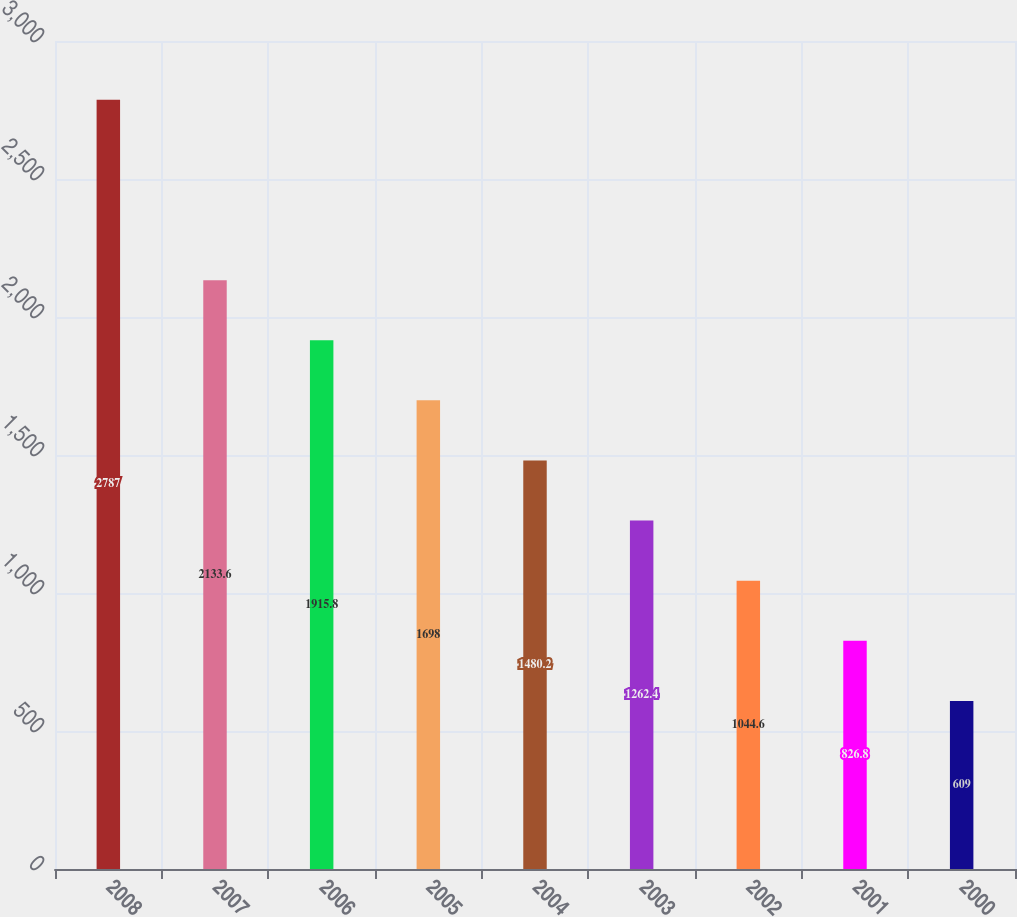Convert chart to OTSL. <chart><loc_0><loc_0><loc_500><loc_500><bar_chart><fcel>2008<fcel>2007<fcel>2006<fcel>2005<fcel>2004<fcel>2003<fcel>2002<fcel>2001<fcel>2000<nl><fcel>2787<fcel>2133.6<fcel>1915.8<fcel>1698<fcel>1480.2<fcel>1262.4<fcel>1044.6<fcel>826.8<fcel>609<nl></chart> 